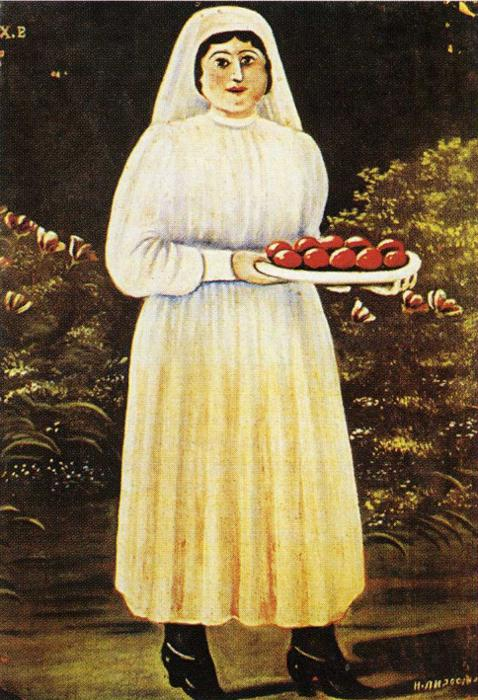What can we infer about the artist's style from this painting? This painting is a classic example of folk art, which often features elements of traditional and cultural significance depicted in a simplistic yet expressive style. The use of bold colors, straightforward composition, and the inclusion of natural and everyday symbols like the tree and apples reflect the artist's intent to convey a narrative that is both relatable and enchanting. The style encourages viewers to appreciate the beauty and symbolism in ordinary surroundings. Is there any significance to the setting depicted behind the woman? Yes, the backdrop setting of dense, dark green foliage juxtaposed with vivid red flowers is symbolic. It serves to frame the central figure, isolating her and drawing focus to her and the tray of apples. This might suggest the woman's connection to nature or her role within her community as a nurturer or provider. The setting adds depth to the painting, enhancing the narrative of abundance and growth. 